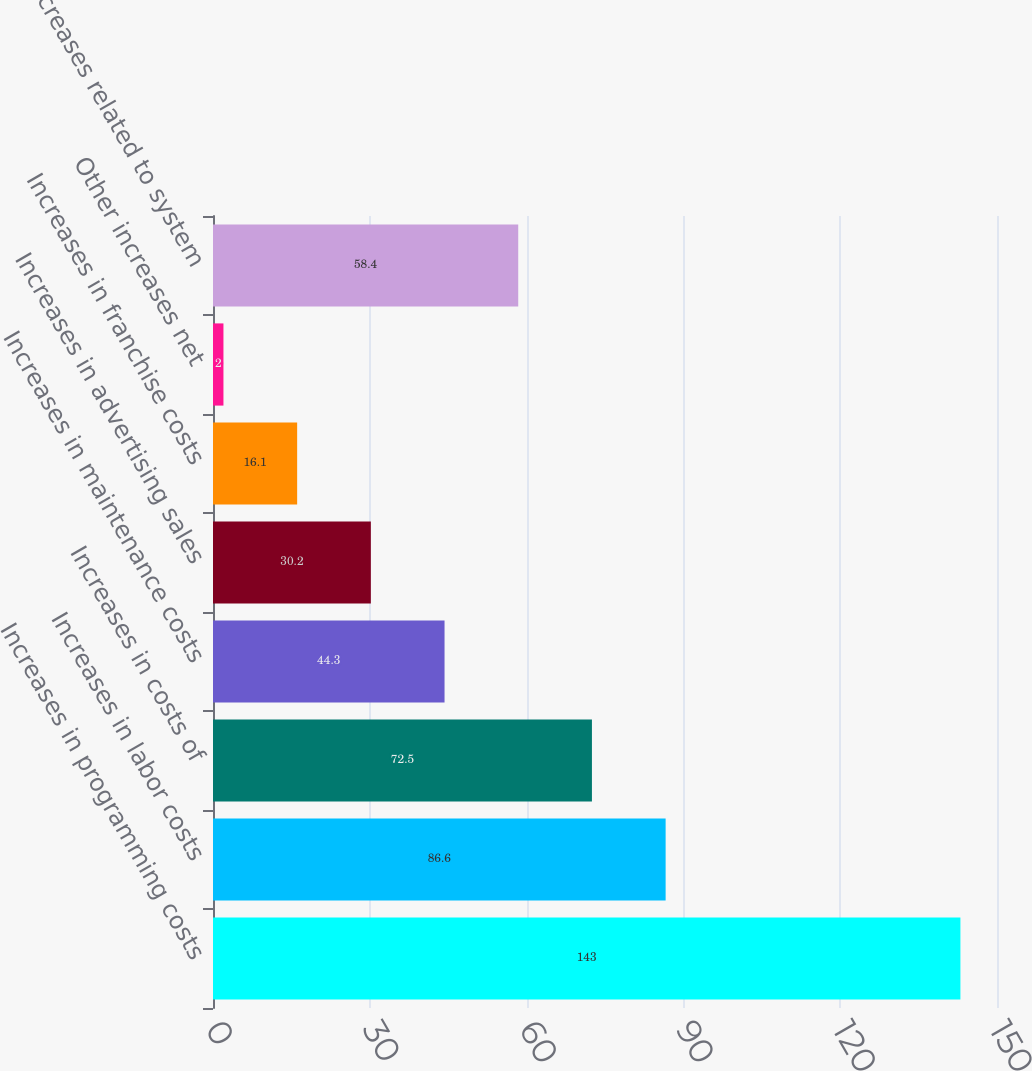<chart> <loc_0><loc_0><loc_500><loc_500><bar_chart><fcel>Increases in programming costs<fcel>Increases in labor costs<fcel>Increases in costs of<fcel>Increases in maintenance costs<fcel>Increases in advertising sales<fcel>Increases in franchise costs<fcel>Other increases net<fcel>Decreases related to system<nl><fcel>143<fcel>86.6<fcel>72.5<fcel>44.3<fcel>30.2<fcel>16.1<fcel>2<fcel>58.4<nl></chart> 